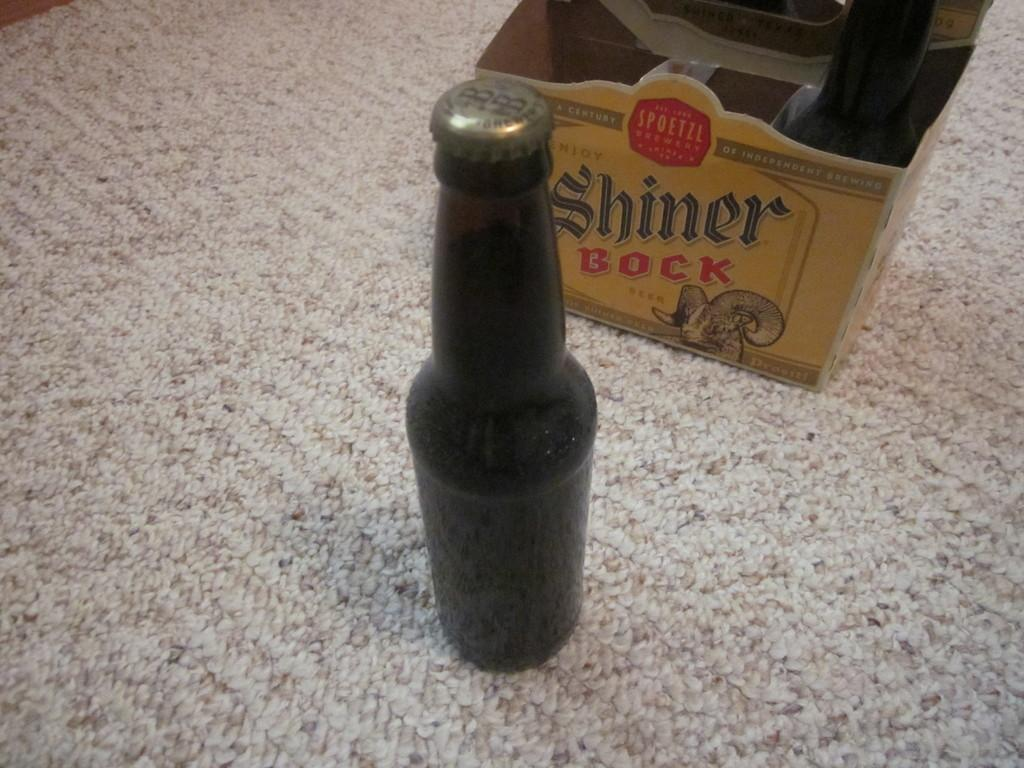<image>
Render a clear and concise summary of the photo. Two bottles of Shiner Bock's beer on the carpet. 